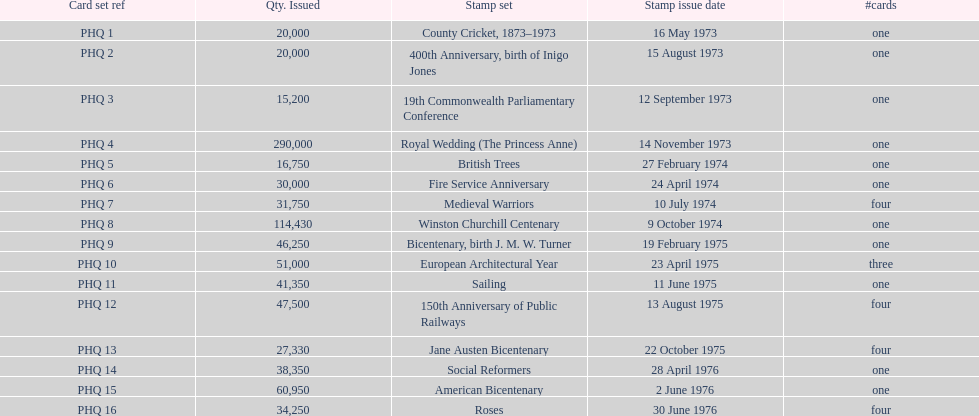Which stamp set had only three cards in the set? European Architectural Year. Give me the full table as a dictionary. {'header': ['Card set ref', 'Qty. Issued', 'Stamp set', 'Stamp issue date', '#cards'], 'rows': [['PHQ 1', '20,000', 'County Cricket, 1873–1973', '16 May 1973', 'one'], ['PHQ 2', '20,000', '400th Anniversary, birth of Inigo Jones', '15 August 1973', 'one'], ['PHQ 3', '15,200', '19th Commonwealth Parliamentary Conference', '12 September 1973', 'one'], ['PHQ 4', '290,000', 'Royal Wedding (The Princess Anne)', '14 November 1973', 'one'], ['PHQ 5', '16,750', 'British Trees', '27 February 1974', 'one'], ['PHQ 6', '30,000', 'Fire Service Anniversary', '24 April 1974', 'one'], ['PHQ 7', '31,750', 'Medieval Warriors', '10 July 1974', 'four'], ['PHQ 8', '114,430', 'Winston Churchill Centenary', '9 October 1974', 'one'], ['PHQ 9', '46,250', 'Bicentenary, birth J. M. W. Turner', '19 February 1975', 'one'], ['PHQ 10', '51,000', 'European Architectural Year', '23 April 1975', 'three'], ['PHQ 11', '41,350', 'Sailing', '11 June 1975', 'one'], ['PHQ 12', '47,500', '150th Anniversary of Public Railways', '13 August 1975', 'four'], ['PHQ 13', '27,330', 'Jane Austen Bicentenary', '22 October 1975', 'four'], ['PHQ 14', '38,350', 'Social Reformers', '28 April 1976', 'one'], ['PHQ 15', '60,950', 'American Bicentenary', '2 June 1976', 'one'], ['PHQ 16', '34,250', 'Roses', '30 June 1976', 'four']]} 